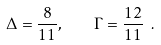<formula> <loc_0><loc_0><loc_500><loc_500>\Delta = \frac { 8 } { 1 1 } , \quad \Gamma = \frac { 1 2 } { 1 1 } \ .</formula> 